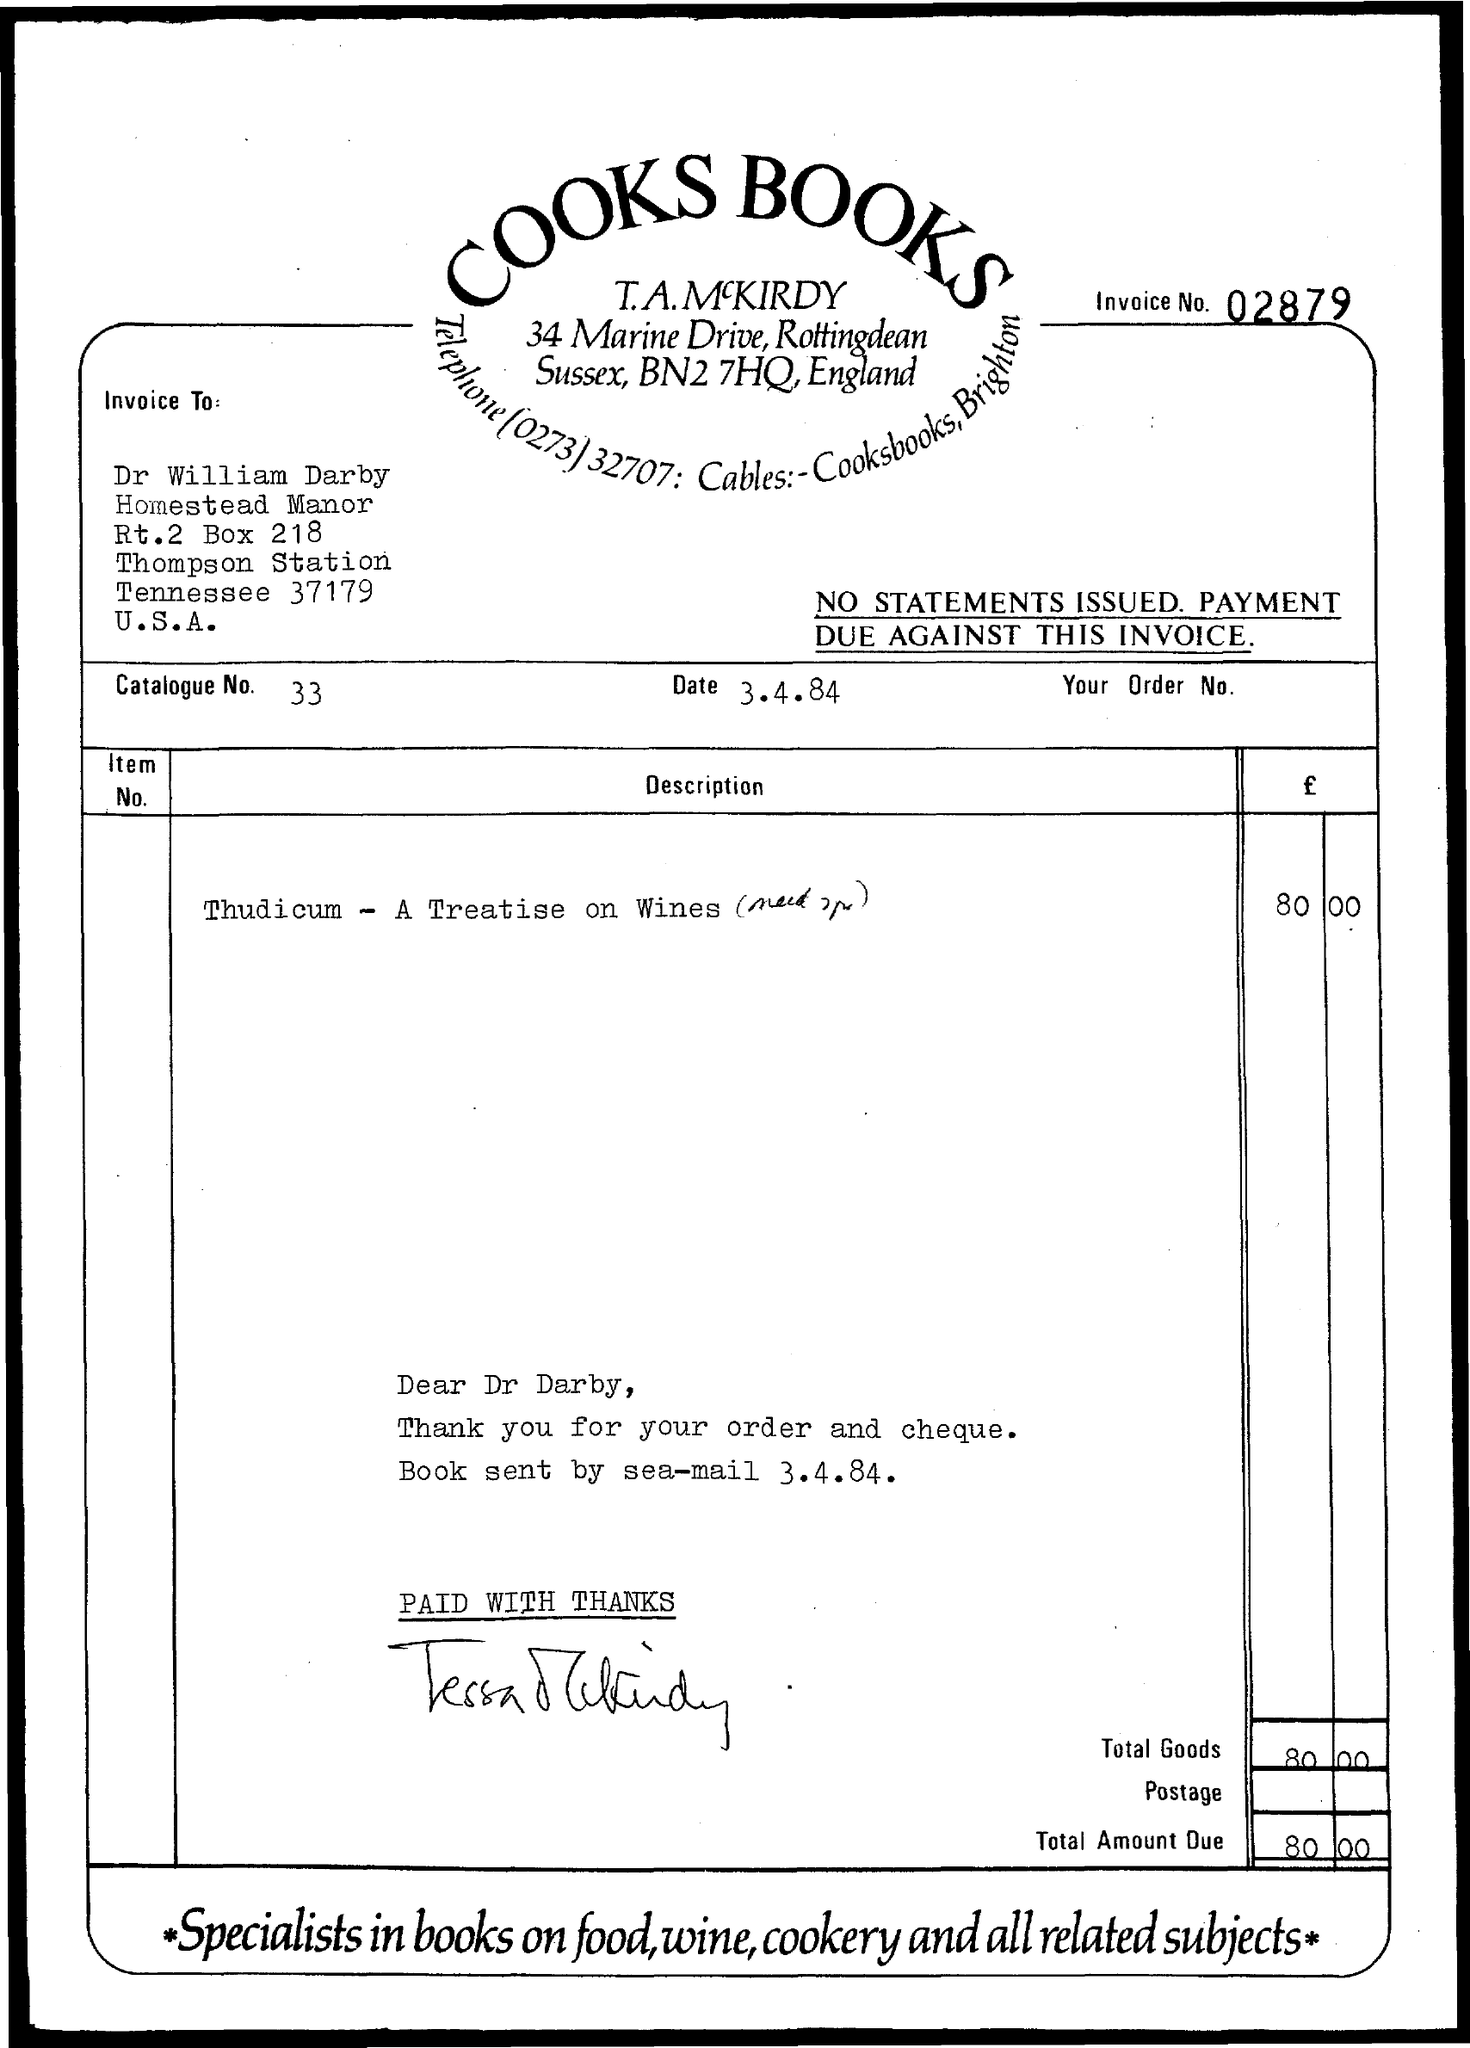Which company has raised the invoice?
Offer a very short reply. COOKS BOOKS. What is the invoice no given?
Your answer should be very brief. 02879. What is the payee's name given in the invoice?
Offer a very short reply. Dr William Darby. What is the invoice date mentioned in this document?
Your response must be concise. 3.4.84. What is the catalogue no. given in the invoice?
Offer a terse response. 33. What is the total amount due in the invoice?
Offer a very short reply. 80 00. 